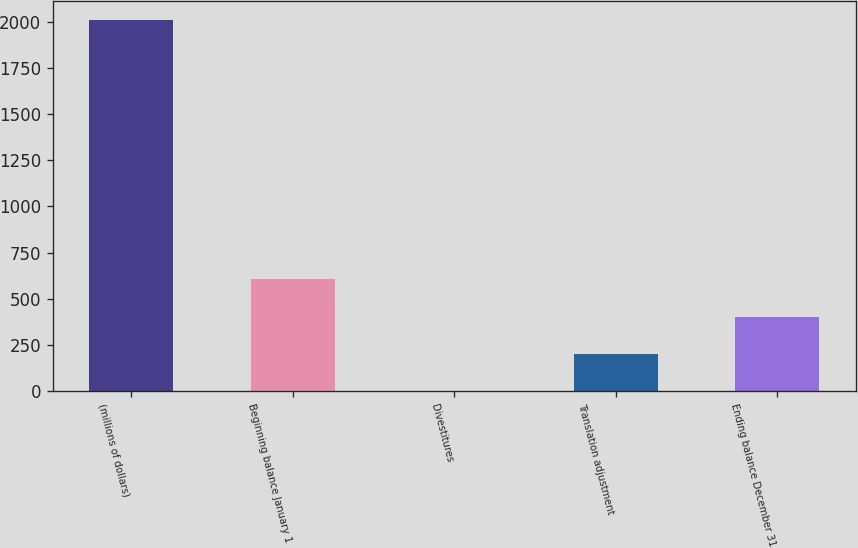<chart> <loc_0><loc_0><loc_500><loc_500><bar_chart><fcel>(millions of dollars)<fcel>Beginning balance January 1<fcel>Divestitures<fcel>Translation adjustment<fcel>Ending balance December 31<nl><fcel>2013<fcel>604.67<fcel>1.1<fcel>202.29<fcel>403.48<nl></chart> 